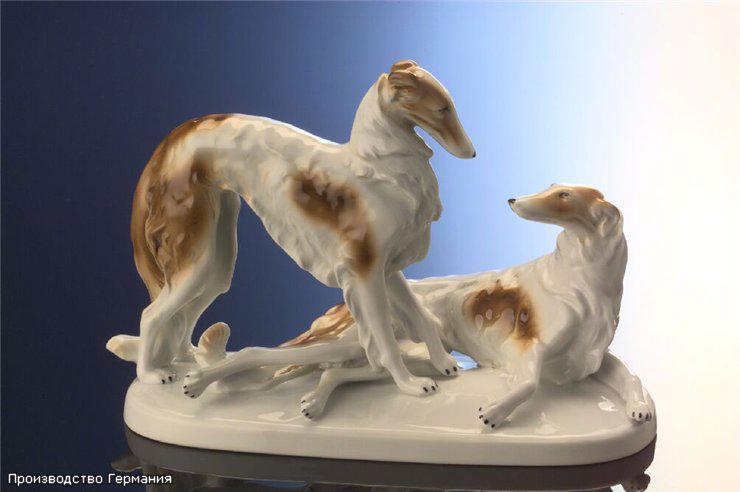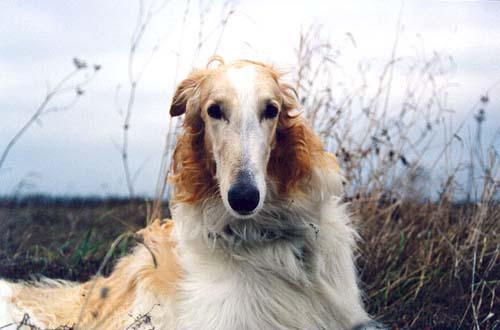The first image is the image on the left, the second image is the image on the right. Given the left and right images, does the statement "One image shows a trio of dogs, with two reclining next to a standing dog." hold true? Answer yes or no. No. The first image is the image on the left, the second image is the image on the right. Given the left and right images, does the statement "One of the two dogs in the image on the left is standing while the other is lying down." hold true? Answer yes or no. Yes. 